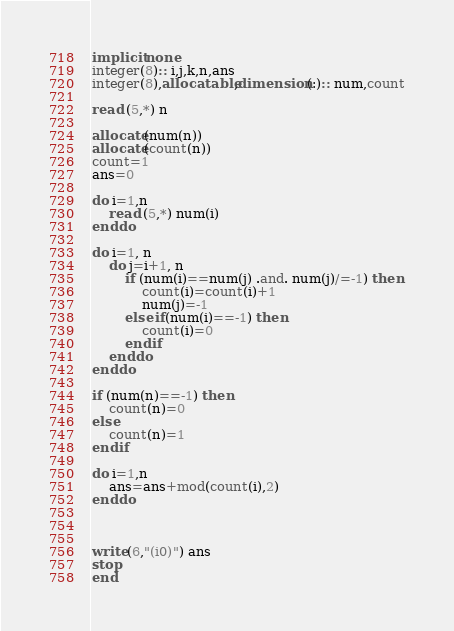Convert code to text. <code><loc_0><loc_0><loc_500><loc_500><_FORTRAN_>implicit none
integer(8):: i,j,k,n,ans
integer(8),allocatable,dimension(:):: num,count
 
read (5,*) n

allocate(num(n))
allocate(count(n))
count=1
ans=0

do i=1,n
    read (5,*) num(i)
enddo

do i=1, n
    do j=i+1, n
        if (num(i)==num(j) .and. num(j)/=-1) then
            count(i)=count(i)+1
            num(j)=-1
        else if(num(i)==-1) then
            count(i)=0
        endif
    enddo
enddo

if (num(n)==-1) then
    count(n)=0
else
    count(n)=1
endif

do i=1,n
    ans=ans+mod(count(i),2)
enddo



write(6,"(i0)") ans
stop
end


</code> 